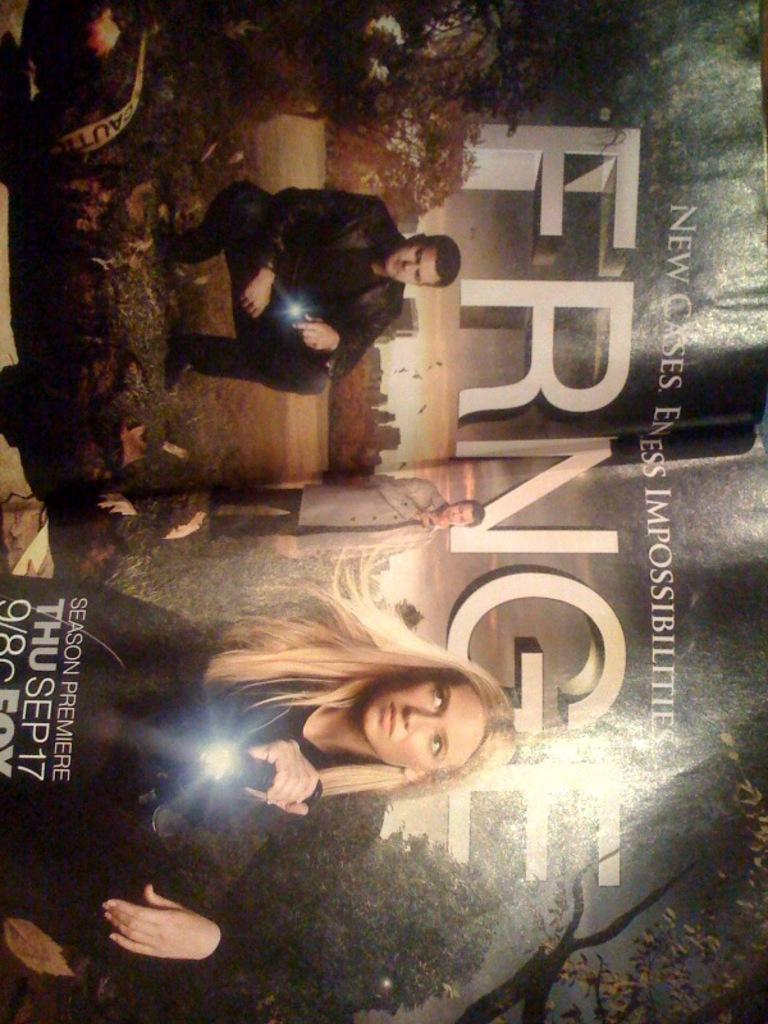<image>
Present a compact description of the photo's key features. A two page magazine ad for a show called Fringe. 